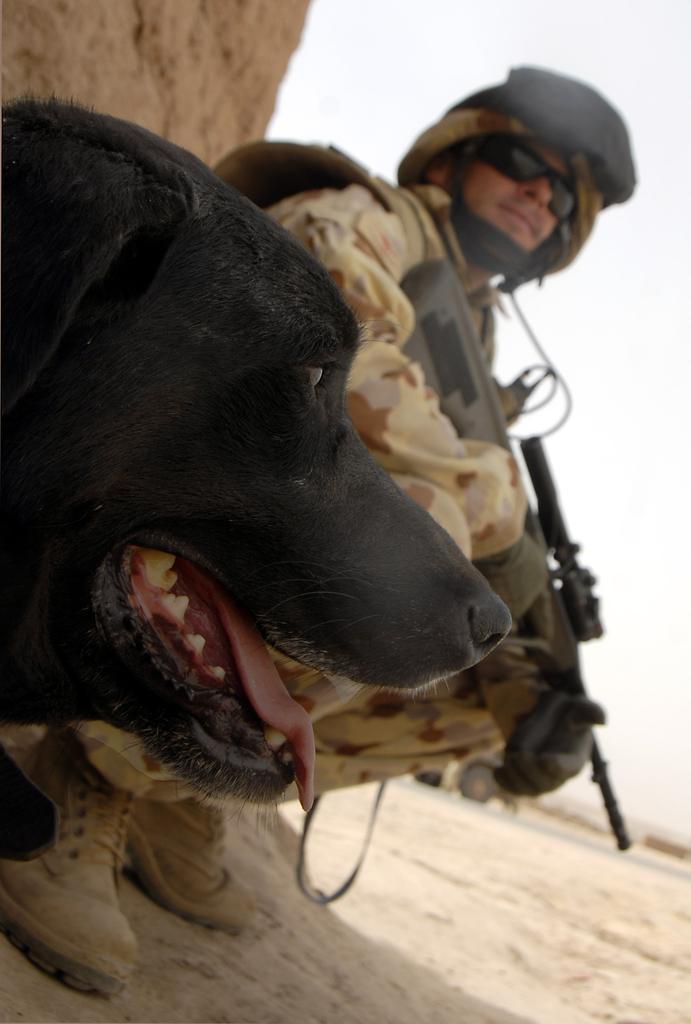In one or two sentences, can you explain what this image depicts? The picture consists of a dog and a soldier. At the bottom there is sand. In the background there is a vehicle on the road. 